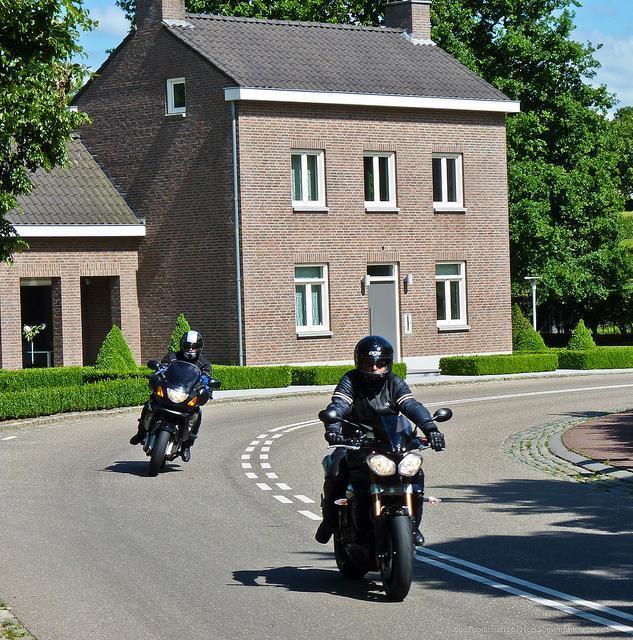How many fireplaces so you see?
Give a very brief answer. 0. How many people are shown?
Give a very brief answer. 2. How many motorcycles are there?
Give a very brief answer. 2. How many people are visible?
Give a very brief answer. 2. 